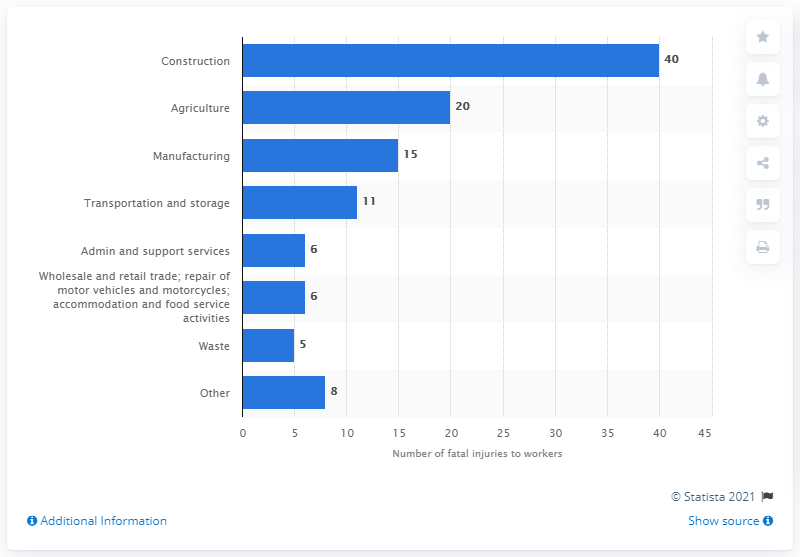Draw attention to some important aspects in this diagram. In the 2019/2020 fiscal year, 40 fatalities occurred in the construction industry. In 2019/20, an estimated 5 workers in the waste industry died. 